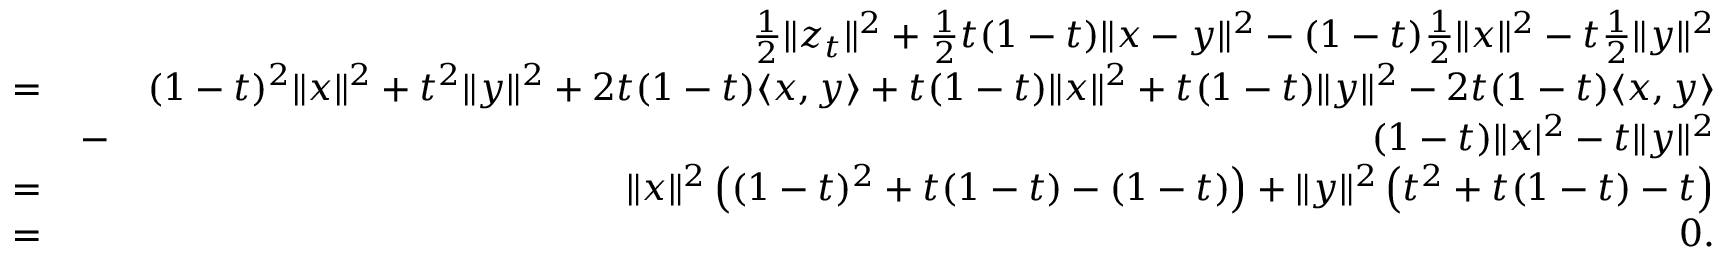<formula> <loc_0><loc_0><loc_500><loc_500>\begin{array} { r l r } & { \frac { 1 } { 2 } \| z _ { t } \| ^ { 2 } + \frac { 1 } { 2 } t ( 1 - t ) \| x - y \| ^ { 2 } - ( 1 - t ) \frac { 1 } { 2 } \| x \| ^ { 2 } - t \frac { 1 } { 2 } \| y \| ^ { 2 } } \\ { = } & { ( 1 - t ) ^ { 2 } \| x \| ^ { 2 } + t ^ { 2 } \| y \| ^ { 2 } + 2 t ( 1 - t ) \langle x , y \rangle + t ( 1 - t ) \| x \| ^ { 2 } + t ( 1 - t ) \| y \| ^ { 2 } - 2 t ( 1 - t ) \langle x , y \rangle } \\ & { - } & { ( 1 - t ) \| x | ^ { 2 } - t \| y \| ^ { 2 } } \\ { = } & { \| x \| ^ { 2 } \left ( ( 1 - t ) ^ { 2 } + t ( 1 - t ) - ( 1 - t ) \right ) + \| y \| ^ { 2 } \left ( t ^ { 2 } + t ( 1 - t ) - t \right ) } \\ { = } & { 0 . } \end{array}</formula> 